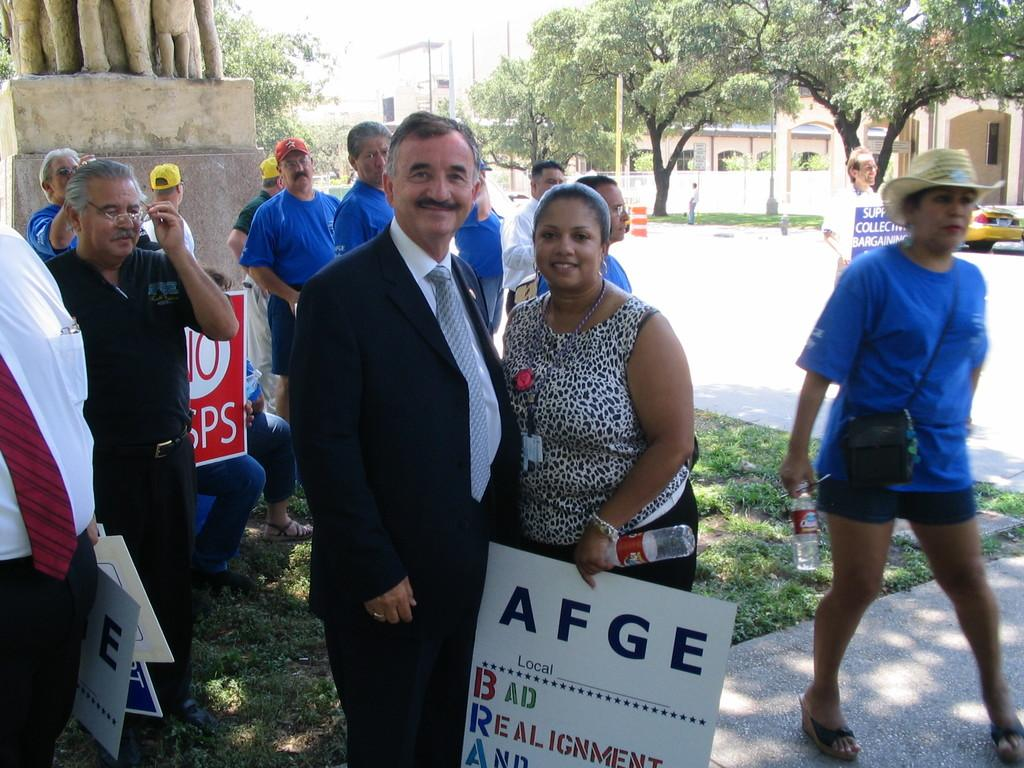How many people can be seen in the image? There are people in the image, but the exact number cannot be determined from the provided facts. What objects are present in the image that resemble boards? There are boards in the image, but their specific purpose or function cannot be determined from the provided facts. What type of containers are visible in the image? There are bottles in the image, but their contents cannot be determined from the provided facts. What type of vegetation is present in the image? There is grass and trees in the image, indicating a natural setting. What type of structures are visible in the image? There are buildings in the image, but their specific purpose or function cannot be determined from the provided facts. What type of vehicle is visible in the image? There is a car in the image, but its color or model cannot be determined from the provided facts. What type of pathway is present in the image? There is a road in the image, but its condition or traffic cannot be determined from the provided facts. What type of vertical structures are visible in the image? There are poles in the image, but their purpose or function cannot be determined from the provided facts. What type of food is being served on the boards in the image? There is no mention of food or boards being used for serving food in the provided facts. 